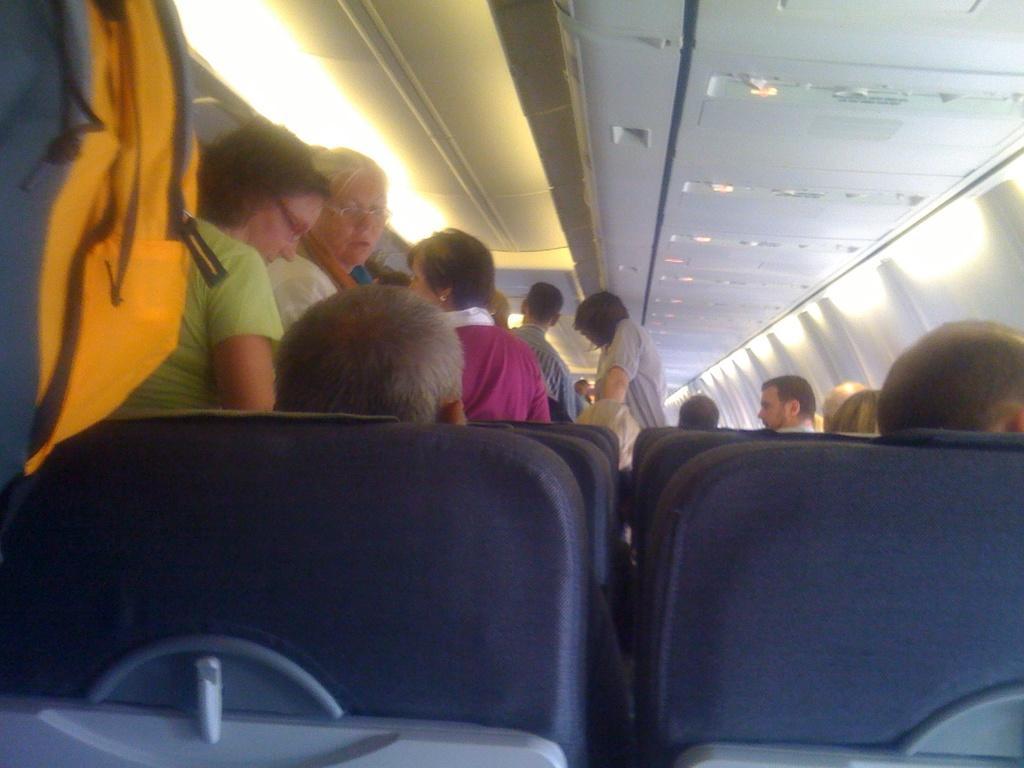How would you summarize this image in a sentence or two? In this image I can see the interior of the vehicle in which I can see few seats, few persons sitting in the seats, few persons standing, the ceiling and few lights to the ceiling. 